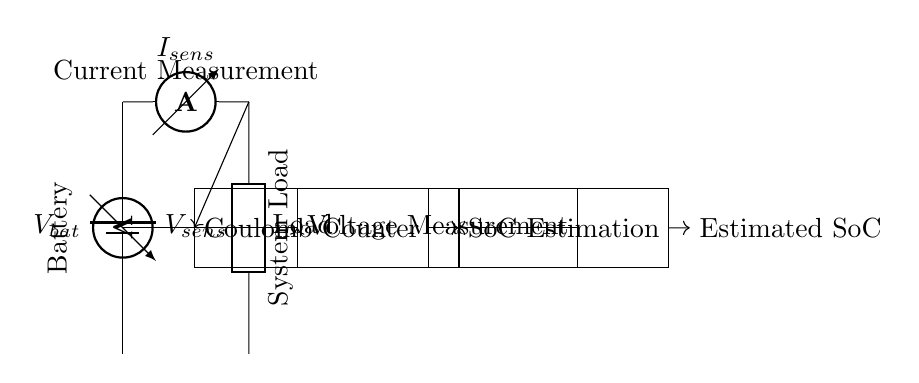What type of sensor is used to measure current? The diagram clearly shows an ammeter labeled as I_sens, which is used to measure current in the circuit.
Answer: ammeter What is the purpose of the Coulomb Counter in this circuit? The Coulomb Counter receives current readings, which it uses to calculate the total charge used over time, essential for determining the state of charge accurately.
Answer: charge estimation Which components are used to measure voltage? The circuit diagram indicates a voltmeter labeled as V_sens connected to the battery, which measures the voltage across it.
Answer: voltmeter How is the estimated state of charge calculated in this circuit? The estimated state of charge is calculated by combining the outputs of both the Coulomb Counter and the Voltage Measurement components, indicating a hybrid approach for accuracy.
Answer: hybrid approach What is the output of the SoC Estimation block? The SoC Estimation block provides an Estimated SoC, which is the final output indicating the state of charge of the battery after processing the inputs.
Answer: Estimated SoC How do the components connect to the load in this circuit? The load connects to the output of the ammeter, indicating that the current flowing through the load is monitored and influenced by the battery and sensors.
Answer: through ammeter 